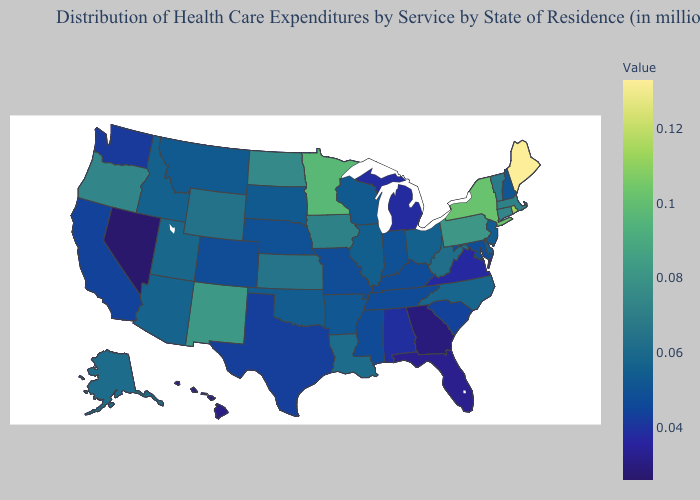Does Delaware have the highest value in the South?
Quick response, please. No. Does Oklahoma have a lower value than New Mexico?
Write a very short answer. Yes. Which states have the lowest value in the West?
Write a very short answer. Nevada. Which states have the highest value in the USA?
Answer briefly. Maine. Does Wyoming have the highest value in the West?
Short answer required. No. Which states have the lowest value in the West?
Write a very short answer. Nevada. Which states have the highest value in the USA?
Quick response, please. Maine. 